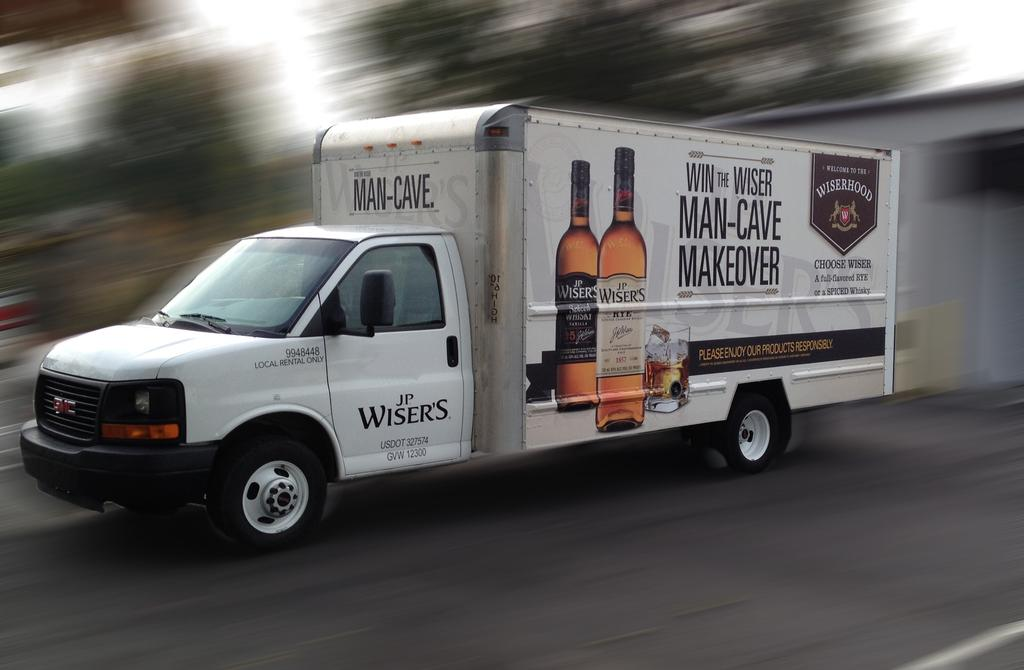<image>
Provide a brief description of the given image. A white cargo truck has the Wisers logo on its drivers side door. 